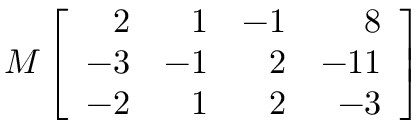<formula> <loc_0><loc_0><loc_500><loc_500>M \left [ { \begin{array} { r r r r } { 2 } & { 1 } & { - 1 } & { 8 } \\ { - 3 } & { - 1 } & { 2 } & { - 1 1 } \\ { - 2 } & { 1 } & { 2 } & { - 3 } \end{array} } \right ]</formula> 